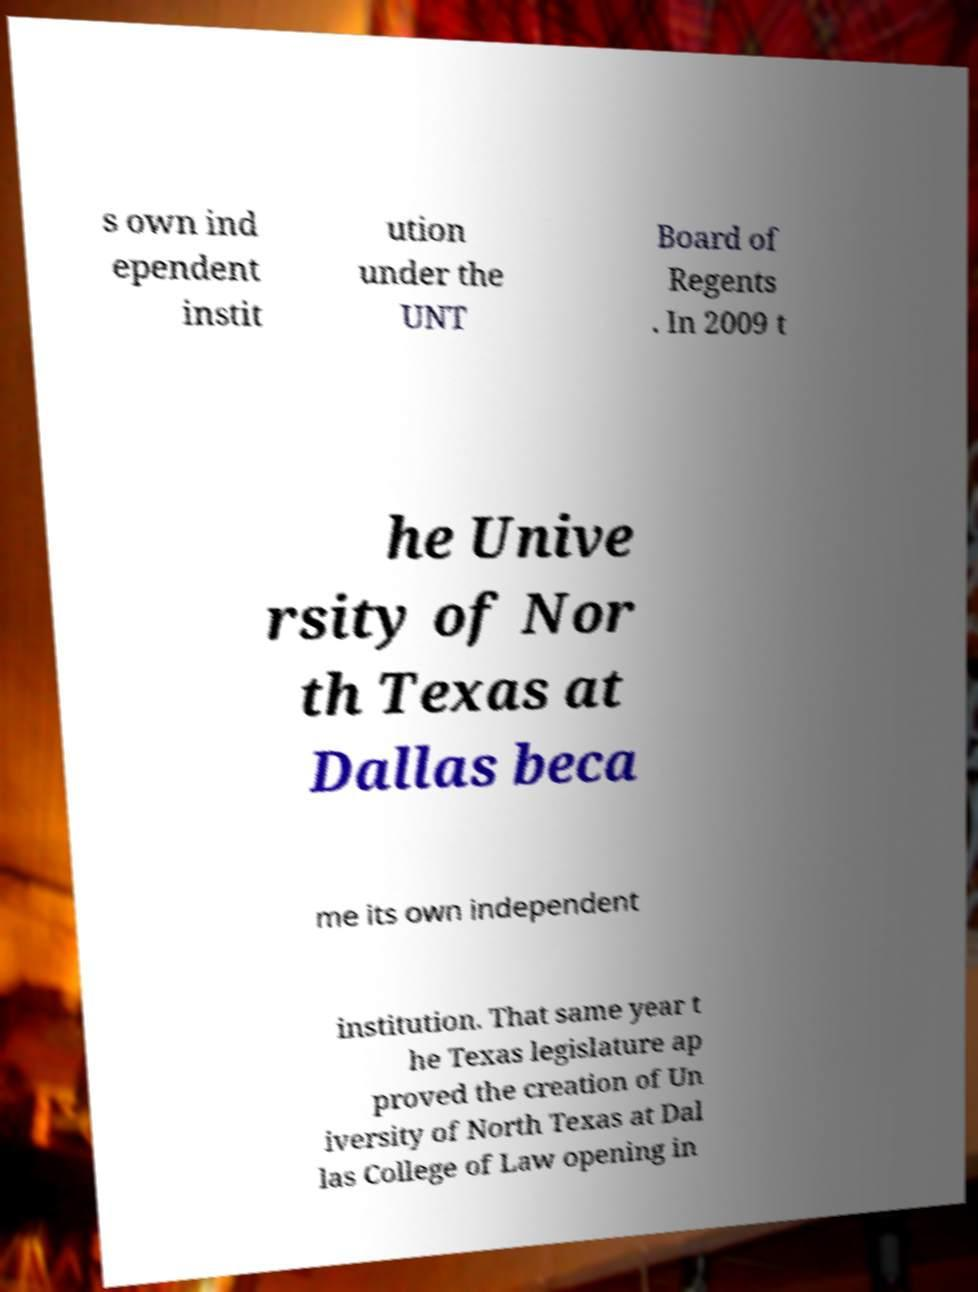For documentation purposes, I need the text within this image transcribed. Could you provide that? s own ind ependent instit ution under the UNT Board of Regents . In 2009 t he Unive rsity of Nor th Texas at Dallas beca me its own independent institution. That same year t he Texas legislature ap proved the creation of Un iversity of North Texas at Dal las College of Law opening in 